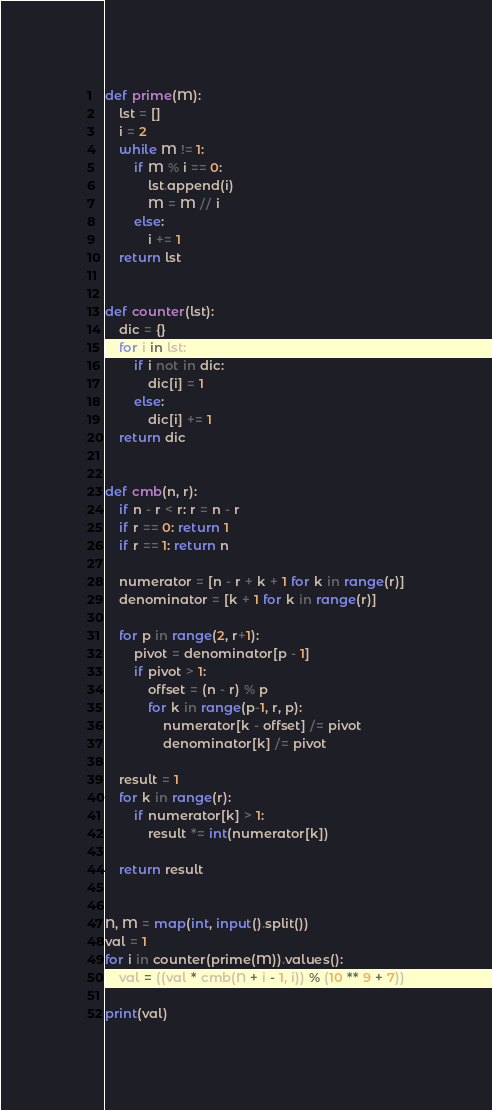Convert code to text. <code><loc_0><loc_0><loc_500><loc_500><_Python_>def prime(M):
    lst = []
    i = 2
    while M != 1:
        if M % i == 0:
            lst.append(i)
            M = M // i
        else:
            i += 1
    return lst


def counter(lst):
    dic = {}
    for i in lst:
        if i not in dic:
            dic[i] = 1
        else:
            dic[i] += 1
    return dic


def cmb(n, r):
    if n - r < r: r = n - r
    if r == 0: return 1
    if r == 1: return n

    numerator = [n - r + k + 1 for k in range(r)]
    denominator = [k + 1 for k in range(r)]

    for p in range(2, r+1):
        pivot = denominator[p - 1]
        if pivot > 1:
            offset = (n - r) % p
            for k in range(p-1, r, p):
                numerator[k - offset] /= pivot
                denominator[k] /= pivot

    result = 1
    for k in range(r):
        if numerator[k] > 1:
            result *= int(numerator[k])

    return result


N, M = map(int, input().split())
val = 1
for i in counter(prime(M)).values():
    val = ((val * cmb(N + i - 1, i)) % (10 ** 9 + 7))
    
print(val)
</code> 